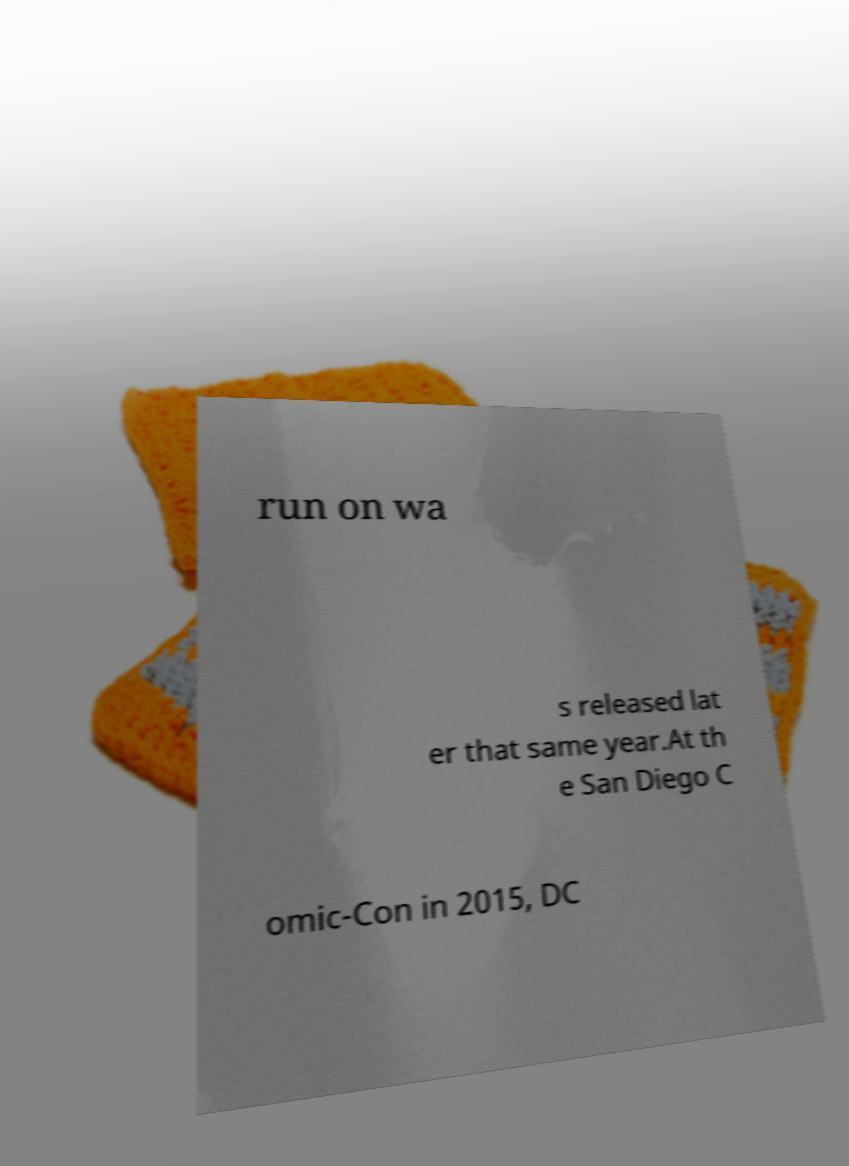Can you read and provide the text displayed in the image?This photo seems to have some interesting text. Can you extract and type it out for me? run on wa s released lat er that same year.At th e San Diego C omic-Con in 2015, DC 